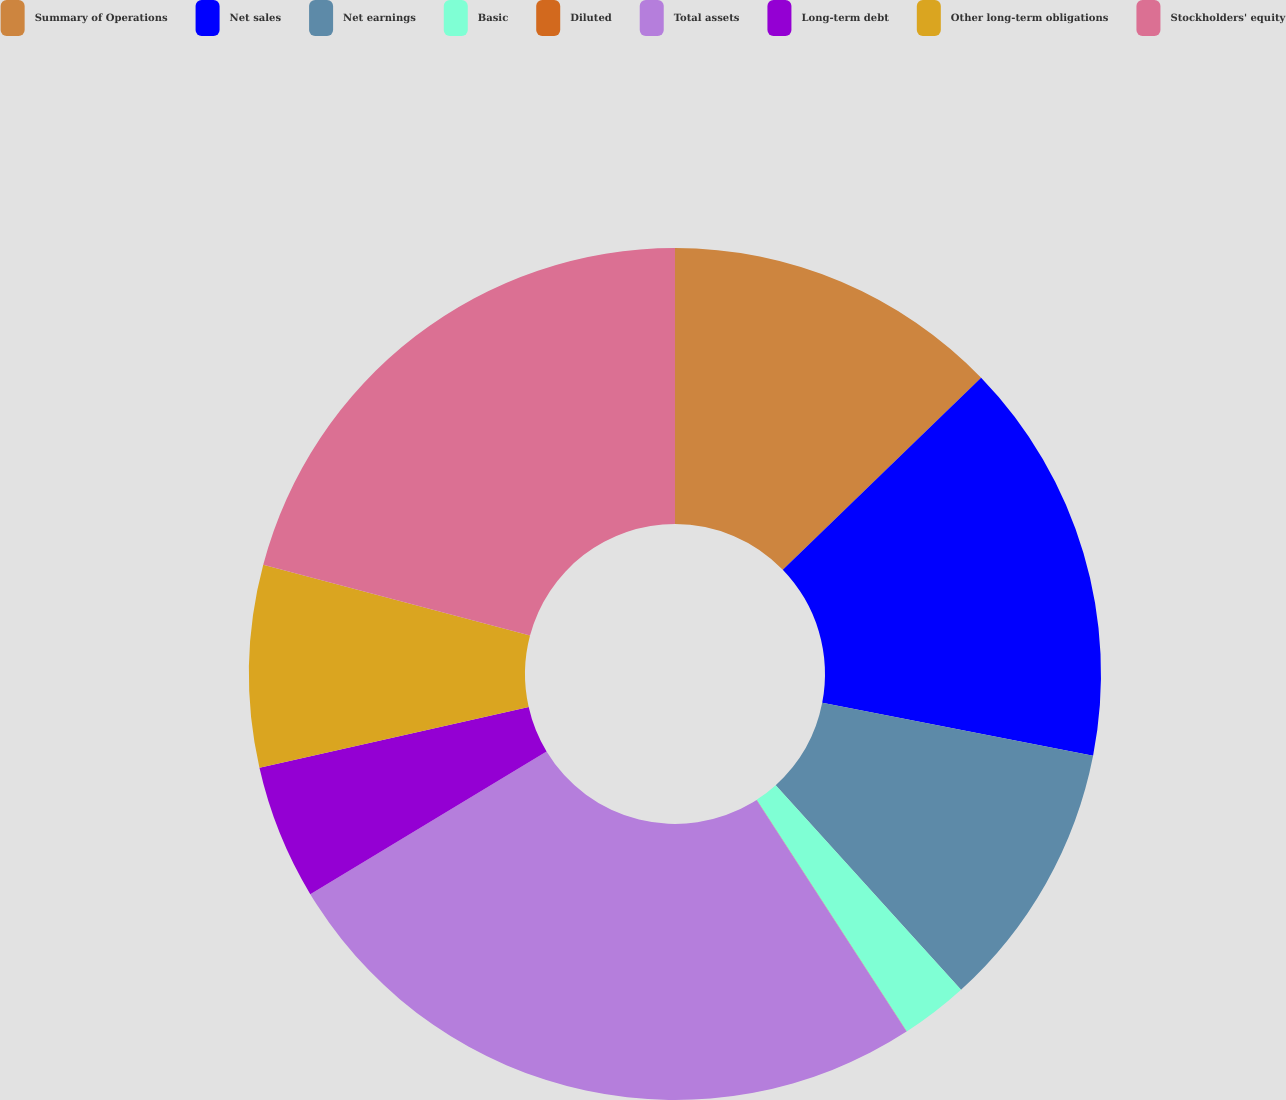Convert chart. <chart><loc_0><loc_0><loc_500><loc_500><pie_chart><fcel>Summary of Operations<fcel>Net sales<fcel>Net earnings<fcel>Basic<fcel>Diluted<fcel>Total assets<fcel>Long-term debt<fcel>Other long-term obligations<fcel>Stockholders' equity<nl><fcel>12.76%<fcel>15.31%<fcel>10.21%<fcel>2.56%<fcel>0.01%<fcel>25.5%<fcel>5.11%<fcel>7.66%<fcel>20.87%<nl></chart> 